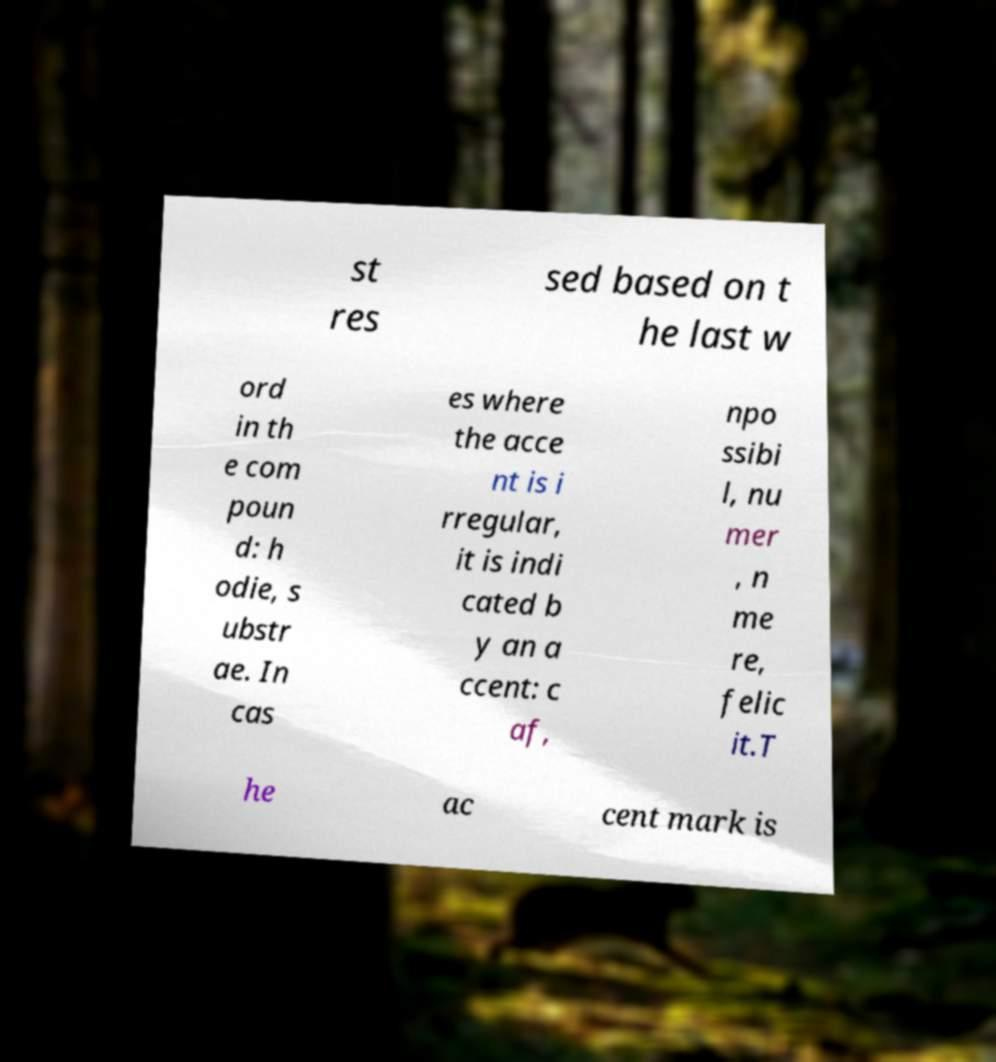Can you accurately transcribe the text from the provided image for me? st res sed based on t he last w ord in th e com poun d: h odie, s ubstr ae. In cas es where the acce nt is i rregular, it is indi cated b y an a ccent: c af, npo ssibi l, nu mer , n me re, felic it.T he ac cent mark is 